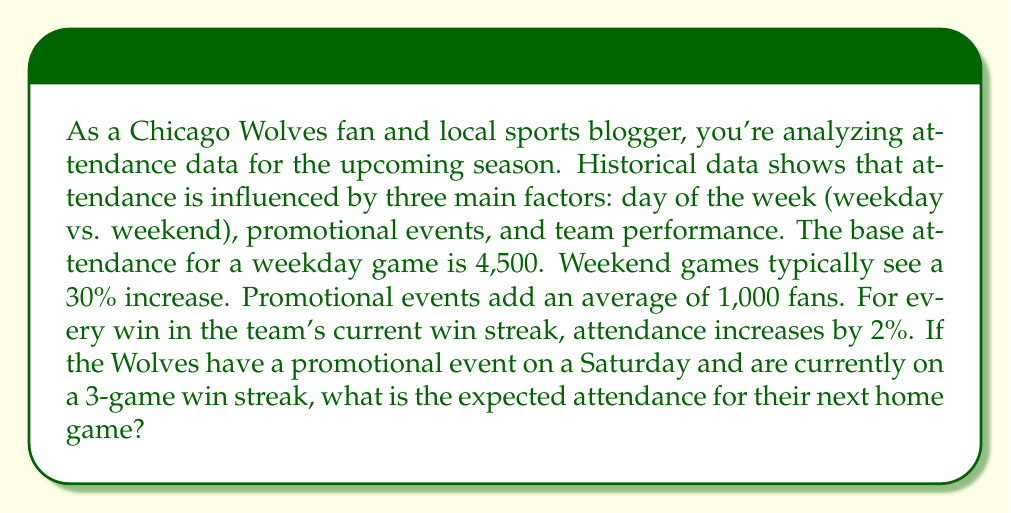Solve this math problem. Let's break this down step-by-step:

1. Base attendance for a weekday game: 4,500

2. Weekend adjustment:
   $$ \text{Weekend increase} = 4,500 \times 0.30 = 1,350 $$
   $$ \text{Weekend base attendance} = 4,500 + 1,350 = 5,850 $$

3. Promotional event impact:
   $$ \text{Attendance after promotion} = 5,850 + 1,000 = 6,850 $$

4. Win streak impact:
   - 3-game win streak means a 6% increase (2% per win)
   $$ \text{Win streak increase} = 6,850 \times 0.06 = 411 $$

5. Final expected attendance:
   $$ \text{Expected attendance} = 6,850 + 411 = 7,261 $$
Answer: The expected attendance for the next Chicago Wolves home game is 7,261 fans. 